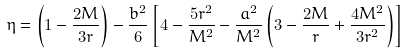<formula> <loc_0><loc_0><loc_500><loc_500>\eta = \left ( 1 - \frac { 2 M } { 3 r } \right ) - \frac { b ^ { 2 } } { 6 } \left [ 4 - \frac { 5 r ^ { 2 } } { M ^ { 2 } } - \frac { a ^ { 2 } } { M ^ { 2 } } \left ( 3 - \frac { 2 M } { r } + \frac { 4 M ^ { 2 } } { 3 r ^ { 2 } } \right ) \right ]</formula> 